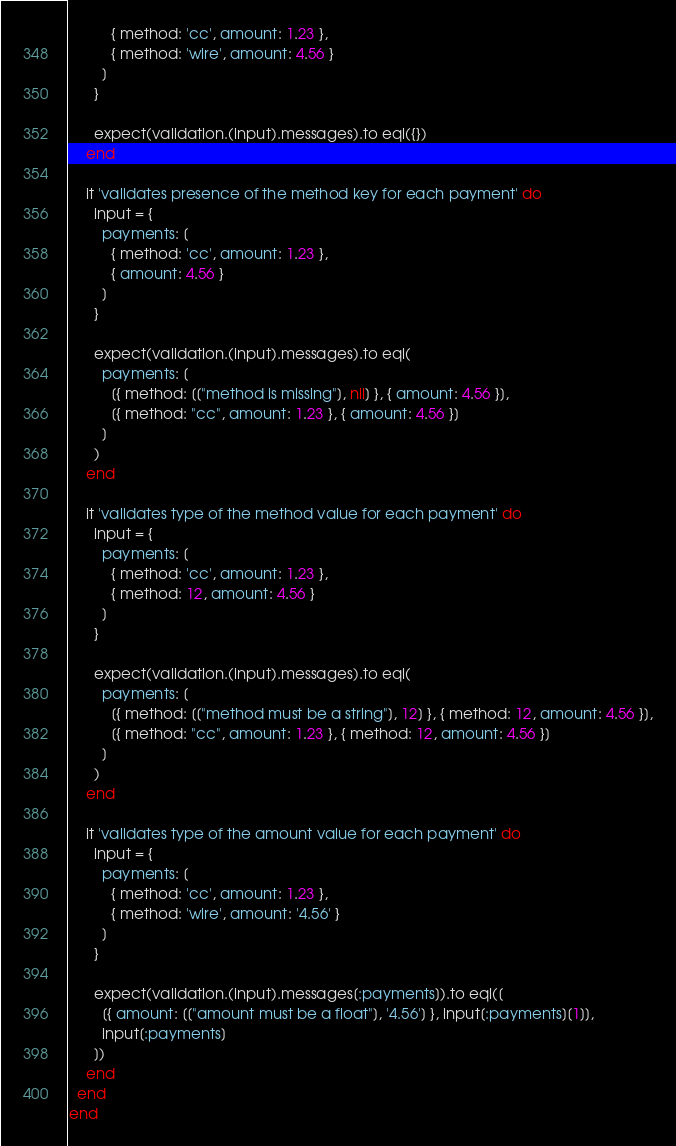<code> <loc_0><loc_0><loc_500><loc_500><_Ruby_>          { method: 'cc', amount: 1.23 },
          { method: 'wire', amount: 4.56 }
        ]
      }

      expect(validation.(input).messages).to eql({})
    end

    it 'validates presence of the method key for each payment' do
      input = {
        payments: [
          { method: 'cc', amount: 1.23 },
          { amount: 4.56 }
        ]
      }

      expect(validation.(input).messages).to eql(
        payments: [
          [{ method: [["method is missing"], nil] }, { amount: 4.56 }],
          [{ method: "cc", amount: 1.23 }, { amount: 4.56 }]
        ]
      )
    end

    it 'validates type of the method value for each payment' do
      input = {
        payments: [
          { method: 'cc', amount: 1.23 },
          { method: 12, amount: 4.56 }
        ]
      }

      expect(validation.(input).messages).to eql(
        payments: [
          [{ method: [["method must be a string"], 12] }, { method: 12, amount: 4.56 }],
          [{ method: "cc", amount: 1.23 }, { method: 12, amount: 4.56 }]
        ]
      )
    end

    it 'validates type of the amount value for each payment' do
      input = {
        payments: [
          { method: 'cc', amount: 1.23 },
          { method: 'wire', amount: '4.56' }
        ]
      }

      expect(validation.(input).messages[:payments]).to eql([
        [{ amount: [["amount must be a float"], '4.56'] }, input[:payments][1]],
        input[:payments]
      ])
    end
  end
end
</code> 